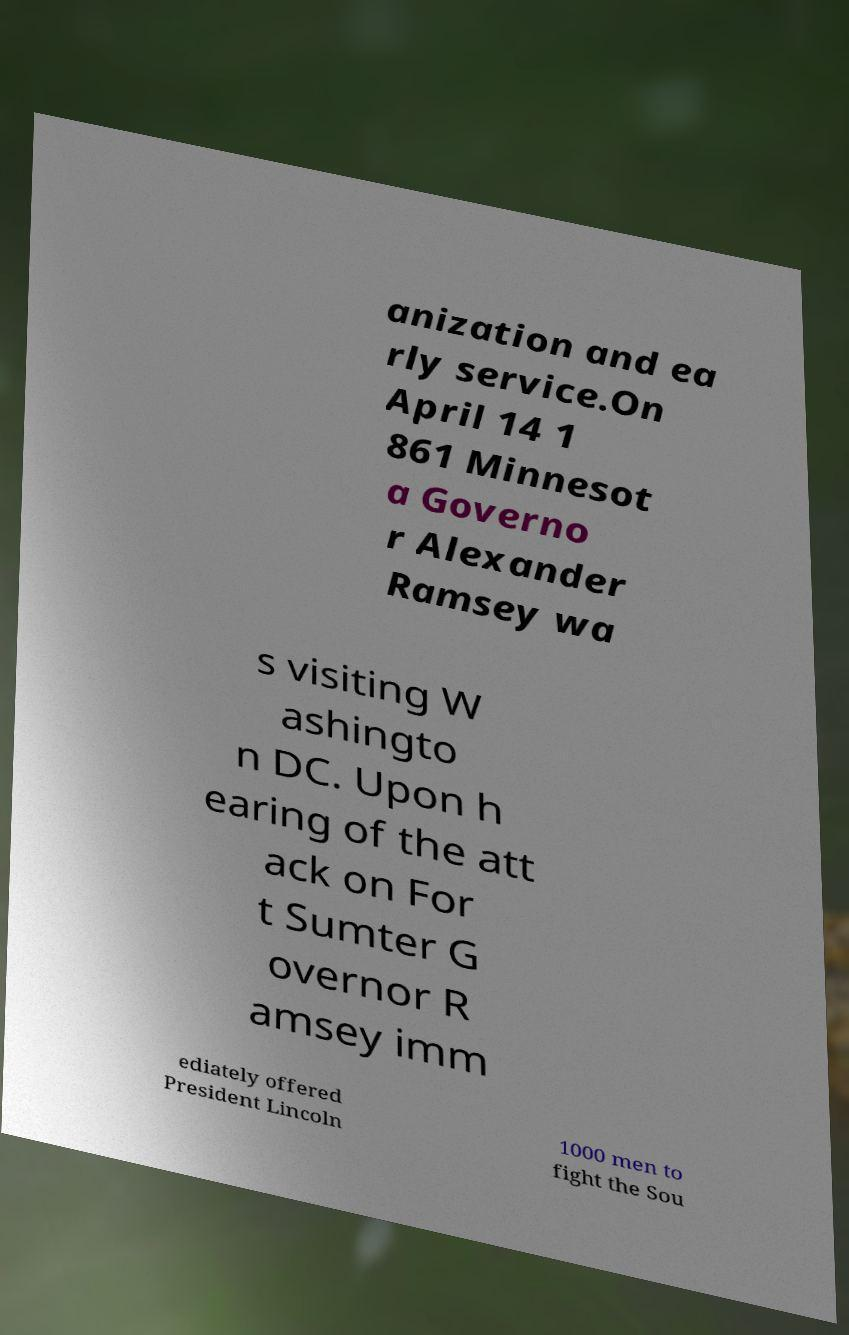I need the written content from this picture converted into text. Can you do that? anization and ea rly service.On April 14 1 861 Minnesot a Governo r Alexander Ramsey wa s visiting W ashingto n DC. Upon h earing of the att ack on For t Sumter G overnor R amsey imm ediately offered President Lincoln 1000 men to fight the Sou 